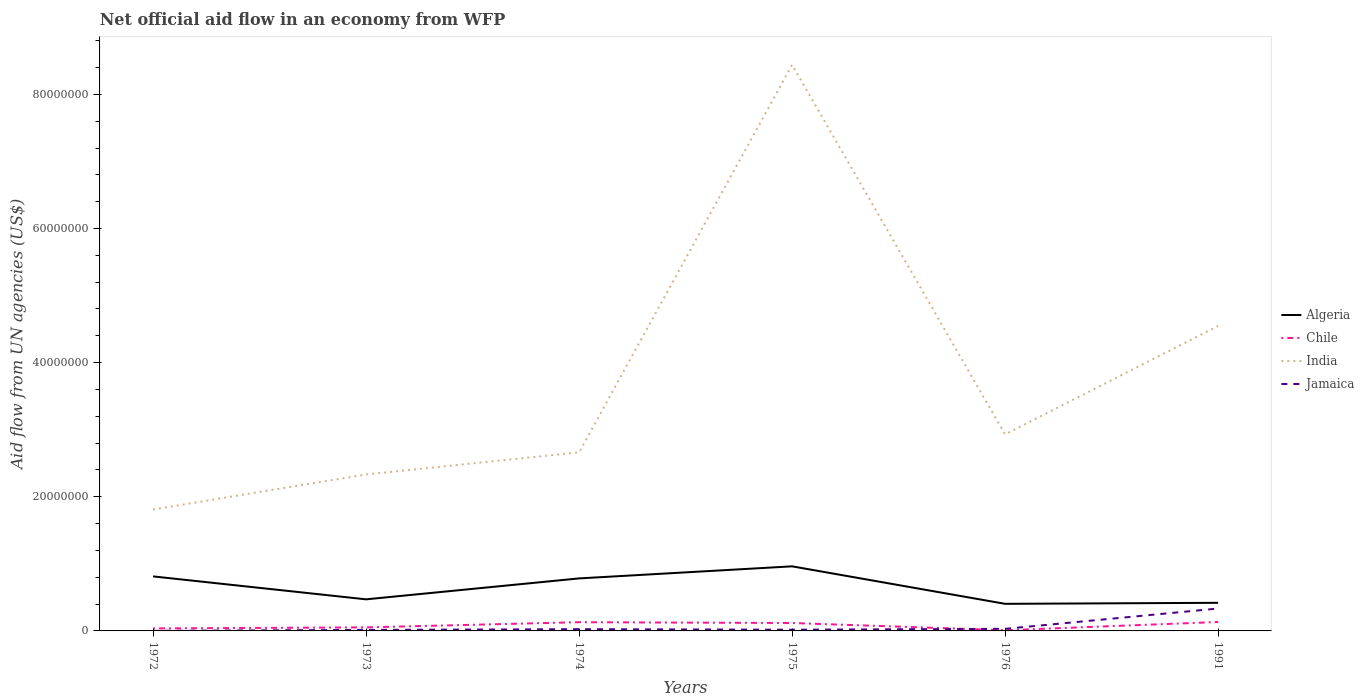How many different coloured lines are there?
Provide a short and direct response. 4. Does the line corresponding to Algeria intersect with the line corresponding to India?
Keep it short and to the point. No. Across all years, what is the maximum net official aid flow in India?
Offer a terse response. 1.81e+07. In which year was the net official aid flow in Algeria maximum?
Make the answer very short. 1976. What is the total net official aid flow in India in the graph?
Provide a succinct answer. -5.78e+07. What is the difference between the highest and the second highest net official aid flow in Algeria?
Your answer should be compact. 5.59e+06. How many lines are there?
Offer a terse response. 4. How many years are there in the graph?
Give a very brief answer. 6. Does the graph contain any zero values?
Make the answer very short. No. Where does the legend appear in the graph?
Your answer should be very brief. Center right. How many legend labels are there?
Make the answer very short. 4. How are the legend labels stacked?
Your answer should be very brief. Vertical. What is the title of the graph?
Make the answer very short. Net official aid flow in an economy from WFP. Does "Equatorial Guinea" appear as one of the legend labels in the graph?
Keep it short and to the point. No. What is the label or title of the Y-axis?
Provide a short and direct response. Aid flow from UN agencies (US$). What is the Aid flow from UN agencies (US$) in Algeria in 1972?
Give a very brief answer. 8.13e+06. What is the Aid flow from UN agencies (US$) in Chile in 1972?
Your answer should be very brief. 3.70e+05. What is the Aid flow from UN agencies (US$) of India in 1972?
Provide a succinct answer. 1.81e+07. What is the Aid flow from UN agencies (US$) in Algeria in 1973?
Your answer should be very brief. 4.71e+06. What is the Aid flow from UN agencies (US$) of Chile in 1973?
Offer a very short reply. 5.30e+05. What is the Aid flow from UN agencies (US$) in India in 1973?
Provide a succinct answer. 2.33e+07. What is the Aid flow from UN agencies (US$) in Algeria in 1974?
Make the answer very short. 7.83e+06. What is the Aid flow from UN agencies (US$) in Chile in 1974?
Your response must be concise. 1.30e+06. What is the Aid flow from UN agencies (US$) in India in 1974?
Ensure brevity in your answer.  2.66e+07. What is the Aid flow from UN agencies (US$) of Jamaica in 1974?
Provide a short and direct response. 2.60e+05. What is the Aid flow from UN agencies (US$) in Algeria in 1975?
Keep it short and to the point. 9.63e+06. What is the Aid flow from UN agencies (US$) of Chile in 1975?
Ensure brevity in your answer.  1.18e+06. What is the Aid flow from UN agencies (US$) in India in 1975?
Your answer should be very brief. 8.44e+07. What is the Aid flow from UN agencies (US$) of Algeria in 1976?
Ensure brevity in your answer.  4.04e+06. What is the Aid flow from UN agencies (US$) of Chile in 1976?
Offer a very short reply. 1.00e+05. What is the Aid flow from UN agencies (US$) in India in 1976?
Keep it short and to the point. 2.93e+07. What is the Aid flow from UN agencies (US$) in Jamaica in 1976?
Ensure brevity in your answer.  3.10e+05. What is the Aid flow from UN agencies (US$) in Algeria in 1991?
Your response must be concise. 4.19e+06. What is the Aid flow from UN agencies (US$) of Chile in 1991?
Your answer should be compact. 1.33e+06. What is the Aid flow from UN agencies (US$) in India in 1991?
Your answer should be compact. 4.55e+07. What is the Aid flow from UN agencies (US$) in Jamaica in 1991?
Provide a succinct answer. 3.34e+06. Across all years, what is the maximum Aid flow from UN agencies (US$) of Algeria?
Provide a short and direct response. 9.63e+06. Across all years, what is the maximum Aid flow from UN agencies (US$) in Chile?
Provide a succinct answer. 1.33e+06. Across all years, what is the maximum Aid flow from UN agencies (US$) of India?
Ensure brevity in your answer.  8.44e+07. Across all years, what is the maximum Aid flow from UN agencies (US$) in Jamaica?
Ensure brevity in your answer.  3.34e+06. Across all years, what is the minimum Aid flow from UN agencies (US$) in Algeria?
Provide a short and direct response. 4.04e+06. Across all years, what is the minimum Aid flow from UN agencies (US$) of Chile?
Provide a succinct answer. 1.00e+05. Across all years, what is the minimum Aid flow from UN agencies (US$) of India?
Ensure brevity in your answer.  1.81e+07. What is the total Aid flow from UN agencies (US$) in Algeria in the graph?
Give a very brief answer. 3.85e+07. What is the total Aid flow from UN agencies (US$) of Chile in the graph?
Provide a short and direct response. 4.81e+06. What is the total Aid flow from UN agencies (US$) of India in the graph?
Your response must be concise. 2.27e+08. What is the total Aid flow from UN agencies (US$) of Jamaica in the graph?
Keep it short and to the point. 4.25e+06. What is the difference between the Aid flow from UN agencies (US$) in Algeria in 1972 and that in 1973?
Ensure brevity in your answer.  3.42e+06. What is the difference between the Aid flow from UN agencies (US$) of Chile in 1972 and that in 1973?
Make the answer very short. -1.60e+05. What is the difference between the Aid flow from UN agencies (US$) in India in 1972 and that in 1973?
Your answer should be very brief. -5.23e+06. What is the difference between the Aid flow from UN agencies (US$) in Algeria in 1972 and that in 1974?
Offer a very short reply. 3.00e+05. What is the difference between the Aid flow from UN agencies (US$) in Chile in 1972 and that in 1974?
Offer a very short reply. -9.30e+05. What is the difference between the Aid flow from UN agencies (US$) of India in 1972 and that in 1974?
Ensure brevity in your answer.  -8.53e+06. What is the difference between the Aid flow from UN agencies (US$) in Jamaica in 1972 and that in 1974?
Keep it short and to the point. -2.50e+05. What is the difference between the Aid flow from UN agencies (US$) of Algeria in 1972 and that in 1975?
Keep it short and to the point. -1.50e+06. What is the difference between the Aid flow from UN agencies (US$) of Chile in 1972 and that in 1975?
Ensure brevity in your answer.  -8.10e+05. What is the difference between the Aid flow from UN agencies (US$) of India in 1972 and that in 1975?
Your response must be concise. -6.63e+07. What is the difference between the Aid flow from UN agencies (US$) of Algeria in 1972 and that in 1976?
Give a very brief answer. 4.09e+06. What is the difference between the Aid flow from UN agencies (US$) of Chile in 1972 and that in 1976?
Offer a very short reply. 2.70e+05. What is the difference between the Aid flow from UN agencies (US$) of India in 1972 and that in 1976?
Your answer should be very brief. -1.12e+07. What is the difference between the Aid flow from UN agencies (US$) of Algeria in 1972 and that in 1991?
Offer a very short reply. 3.94e+06. What is the difference between the Aid flow from UN agencies (US$) in Chile in 1972 and that in 1991?
Your response must be concise. -9.60e+05. What is the difference between the Aid flow from UN agencies (US$) of India in 1972 and that in 1991?
Your answer should be compact. -2.74e+07. What is the difference between the Aid flow from UN agencies (US$) in Jamaica in 1972 and that in 1991?
Provide a short and direct response. -3.33e+06. What is the difference between the Aid flow from UN agencies (US$) of Algeria in 1973 and that in 1974?
Ensure brevity in your answer.  -3.12e+06. What is the difference between the Aid flow from UN agencies (US$) in Chile in 1973 and that in 1974?
Provide a succinct answer. -7.70e+05. What is the difference between the Aid flow from UN agencies (US$) in India in 1973 and that in 1974?
Make the answer very short. -3.30e+06. What is the difference between the Aid flow from UN agencies (US$) in Jamaica in 1973 and that in 1974?
Your response must be concise. -1.10e+05. What is the difference between the Aid flow from UN agencies (US$) of Algeria in 1973 and that in 1975?
Your answer should be very brief. -4.92e+06. What is the difference between the Aid flow from UN agencies (US$) of Chile in 1973 and that in 1975?
Offer a very short reply. -6.50e+05. What is the difference between the Aid flow from UN agencies (US$) of India in 1973 and that in 1975?
Keep it short and to the point. -6.11e+07. What is the difference between the Aid flow from UN agencies (US$) in Algeria in 1973 and that in 1976?
Your answer should be compact. 6.70e+05. What is the difference between the Aid flow from UN agencies (US$) of Chile in 1973 and that in 1976?
Keep it short and to the point. 4.30e+05. What is the difference between the Aid flow from UN agencies (US$) of India in 1973 and that in 1976?
Your answer should be very brief. -5.98e+06. What is the difference between the Aid flow from UN agencies (US$) of Algeria in 1973 and that in 1991?
Provide a short and direct response. 5.20e+05. What is the difference between the Aid flow from UN agencies (US$) in Chile in 1973 and that in 1991?
Offer a very short reply. -8.00e+05. What is the difference between the Aid flow from UN agencies (US$) in India in 1973 and that in 1991?
Offer a terse response. -2.21e+07. What is the difference between the Aid flow from UN agencies (US$) in Jamaica in 1973 and that in 1991?
Offer a terse response. -3.19e+06. What is the difference between the Aid flow from UN agencies (US$) of Algeria in 1974 and that in 1975?
Give a very brief answer. -1.80e+06. What is the difference between the Aid flow from UN agencies (US$) in India in 1974 and that in 1975?
Provide a succinct answer. -5.78e+07. What is the difference between the Aid flow from UN agencies (US$) of Jamaica in 1974 and that in 1975?
Provide a succinct answer. 8.00e+04. What is the difference between the Aid flow from UN agencies (US$) in Algeria in 1974 and that in 1976?
Keep it short and to the point. 3.79e+06. What is the difference between the Aid flow from UN agencies (US$) of Chile in 1974 and that in 1976?
Offer a terse response. 1.20e+06. What is the difference between the Aid flow from UN agencies (US$) in India in 1974 and that in 1976?
Your answer should be compact. -2.68e+06. What is the difference between the Aid flow from UN agencies (US$) of Jamaica in 1974 and that in 1976?
Offer a very short reply. -5.00e+04. What is the difference between the Aid flow from UN agencies (US$) in Algeria in 1974 and that in 1991?
Provide a short and direct response. 3.64e+06. What is the difference between the Aid flow from UN agencies (US$) of India in 1974 and that in 1991?
Ensure brevity in your answer.  -1.88e+07. What is the difference between the Aid flow from UN agencies (US$) of Jamaica in 1974 and that in 1991?
Offer a terse response. -3.08e+06. What is the difference between the Aid flow from UN agencies (US$) in Algeria in 1975 and that in 1976?
Provide a short and direct response. 5.59e+06. What is the difference between the Aid flow from UN agencies (US$) of Chile in 1975 and that in 1976?
Provide a short and direct response. 1.08e+06. What is the difference between the Aid flow from UN agencies (US$) of India in 1975 and that in 1976?
Your answer should be very brief. 5.51e+07. What is the difference between the Aid flow from UN agencies (US$) in Jamaica in 1975 and that in 1976?
Make the answer very short. -1.30e+05. What is the difference between the Aid flow from UN agencies (US$) in Algeria in 1975 and that in 1991?
Your answer should be very brief. 5.44e+06. What is the difference between the Aid flow from UN agencies (US$) in India in 1975 and that in 1991?
Your answer should be compact. 3.89e+07. What is the difference between the Aid flow from UN agencies (US$) in Jamaica in 1975 and that in 1991?
Give a very brief answer. -3.16e+06. What is the difference between the Aid flow from UN agencies (US$) in Chile in 1976 and that in 1991?
Keep it short and to the point. -1.23e+06. What is the difference between the Aid flow from UN agencies (US$) of India in 1976 and that in 1991?
Your response must be concise. -1.62e+07. What is the difference between the Aid flow from UN agencies (US$) in Jamaica in 1976 and that in 1991?
Make the answer very short. -3.03e+06. What is the difference between the Aid flow from UN agencies (US$) of Algeria in 1972 and the Aid flow from UN agencies (US$) of Chile in 1973?
Keep it short and to the point. 7.60e+06. What is the difference between the Aid flow from UN agencies (US$) in Algeria in 1972 and the Aid flow from UN agencies (US$) in India in 1973?
Your response must be concise. -1.52e+07. What is the difference between the Aid flow from UN agencies (US$) in Algeria in 1972 and the Aid flow from UN agencies (US$) in Jamaica in 1973?
Keep it short and to the point. 7.98e+06. What is the difference between the Aid flow from UN agencies (US$) in Chile in 1972 and the Aid flow from UN agencies (US$) in India in 1973?
Provide a succinct answer. -2.30e+07. What is the difference between the Aid flow from UN agencies (US$) in Chile in 1972 and the Aid flow from UN agencies (US$) in Jamaica in 1973?
Ensure brevity in your answer.  2.20e+05. What is the difference between the Aid flow from UN agencies (US$) in India in 1972 and the Aid flow from UN agencies (US$) in Jamaica in 1973?
Keep it short and to the point. 1.80e+07. What is the difference between the Aid flow from UN agencies (US$) in Algeria in 1972 and the Aid flow from UN agencies (US$) in Chile in 1974?
Make the answer very short. 6.83e+06. What is the difference between the Aid flow from UN agencies (US$) of Algeria in 1972 and the Aid flow from UN agencies (US$) of India in 1974?
Provide a succinct answer. -1.85e+07. What is the difference between the Aid flow from UN agencies (US$) in Algeria in 1972 and the Aid flow from UN agencies (US$) in Jamaica in 1974?
Your response must be concise. 7.87e+06. What is the difference between the Aid flow from UN agencies (US$) in Chile in 1972 and the Aid flow from UN agencies (US$) in India in 1974?
Offer a very short reply. -2.63e+07. What is the difference between the Aid flow from UN agencies (US$) in India in 1972 and the Aid flow from UN agencies (US$) in Jamaica in 1974?
Offer a terse response. 1.78e+07. What is the difference between the Aid flow from UN agencies (US$) of Algeria in 1972 and the Aid flow from UN agencies (US$) of Chile in 1975?
Provide a short and direct response. 6.95e+06. What is the difference between the Aid flow from UN agencies (US$) in Algeria in 1972 and the Aid flow from UN agencies (US$) in India in 1975?
Offer a very short reply. -7.63e+07. What is the difference between the Aid flow from UN agencies (US$) in Algeria in 1972 and the Aid flow from UN agencies (US$) in Jamaica in 1975?
Provide a short and direct response. 7.95e+06. What is the difference between the Aid flow from UN agencies (US$) of Chile in 1972 and the Aid flow from UN agencies (US$) of India in 1975?
Ensure brevity in your answer.  -8.40e+07. What is the difference between the Aid flow from UN agencies (US$) in Chile in 1972 and the Aid flow from UN agencies (US$) in Jamaica in 1975?
Give a very brief answer. 1.90e+05. What is the difference between the Aid flow from UN agencies (US$) in India in 1972 and the Aid flow from UN agencies (US$) in Jamaica in 1975?
Provide a short and direct response. 1.79e+07. What is the difference between the Aid flow from UN agencies (US$) in Algeria in 1972 and the Aid flow from UN agencies (US$) in Chile in 1976?
Offer a very short reply. 8.03e+06. What is the difference between the Aid flow from UN agencies (US$) of Algeria in 1972 and the Aid flow from UN agencies (US$) of India in 1976?
Your answer should be very brief. -2.12e+07. What is the difference between the Aid flow from UN agencies (US$) in Algeria in 1972 and the Aid flow from UN agencies (US$) in Jamaica in 1976?
Ensure brevity in your answer.  7.82e+06. What is the difference between the Aid flow from UN agencies (US$) in Chile in 1972 and the Aid flow from UN agencies (US$) in India in 1976?
Provide a short and direct response. -2.89e+07. What is the difference between the Aid flow from UN agencies (US$) in India in 1972 and the Aid flow from UN agencies (US$) in Jamaica in 1976?
Ensure brevity in your answer.  1.78e+07. What is the difference between the Aid flow from UN agencies (US$) of Algeria in 1972 and the Aid flow from UN agencies (US$) of Chile in 1991?
Provide a succinct answer. 6.80e+06. What is the difference between the Aid flow from UN agencies (US$) in Algeria in 1972 and the Aid flow from UN agencies (US$) in India in 1991?
Provide a succinct answer. -3.73e+07. What is the difference between the Aid flow from UN agencies (US$) in Algeria in 1972 and the Aid flow from UN agencies (US$) in Jamaica in 1991?
Provide a succinct answer. 4.79e+06. What is the difference between the Aid flow from UN agencies (US$) in Chile in 1972 and the Aid flow from UN agencies (US$) in India in 1991?
Give a very brief answer. -4.51e+07. What is the difference between the Aid flow from UN agencies (US$) in Chile in 1972 and the Aid flow from UN agencies (US$) in Jamaica in 1991?
Your answer should be very brief. -2.97e+06. What is the difference between the Aid flow from UN agencies (US$) in India in 1972 and the Aid flow from UN agencies (US$) in Jamaica in 1991?
Ensure brevity in your answer.  1.48e+07. What is the difference between the Aid flow from UN agencies (US$) of Algeria in 1973 and the Aid flow from UN agencies (US$) of Chile in 1974?
Offer a very short reply. 3.41e+06. What is the difference between the Aid flow from UN agencies (US$) in Algeria in 1973 and the Aid flow from UN agencies (US$) in India in 1974?
Ensure brevity in your answer.  -2.19e+07. What is the difference between the Aid flow from UN agencies (US$) in Algeria in 1973 and the Aid flow from UN agencies (US$) in Jamaica in 1974?
Keep it short and to the point. 4.45e+06. What is the difference between the Aid flow from UN agencies (US$) in Chile in 1973 and the Aid flow from UN agencies (US$) in India in 1974?
Provide a short and direct response. -2.61e+07. What is the difference between the Aid flow from UN agencies (US$) in India in 1973 and the Aid flow from UN agencies (US$) in Jamaica in 1974?
Your answer should be compact. 2.31e+07. What is the difference between the Aid flow from UN agencies (US$) of Algeria in 1973 and the Aid flow from UN agencies (US$) of Chile in 1975?
Provide a succinct answer. 3.53e+06. What is the difference between the Aid flow from UN agencies (US$) of Algeria in 1973 and the Aid flow from UN agencies (US$) of India in 1975?
Keep it short and to the point. -7.97e+07. What is the difference between the Aid flow from UN agencies (US$) of Algeria in 1973 and the Aid flow from UN agencies (US$) of Jamaica in 1975?
Your response must be concise. 4.53e+06. What is the difference between the Aid flow from UN agencies (US$) of Chile in 1973 and the Aid flow from UN agencies (US$) of India in 1975?
Keep it short and to the point. -8.39e+07. What is the difference between the Aid flow from UN agencies (US$) of India in 1973 and the Aid flow from UN agencies (US$) of Jamaica in 1975?
Your answer should be compact. 2.32e+07. What is the difference between the Aid flow from UN agencies (US$) of Algeria in 1973 and the Aid flow from UN agencies (US$) of Chile in 1976?
Keep it short and to the point. 4.61e+06. What is the difference between the Aid flow from UN agencies (US$) in Algeria in 1973 and the Aid flow from UN agencies (US$) in India in 1976?
Ensure brevity in your answer.  -2.46e+07. What is the difference between the Aid flow from UN agencies (US$) in Algeria in 1973 and the Aid flow from UN agencies (US$) in Jamaica in 1976?
Provide a short and direct response. 4.40e+06. What is the difference between the Aid flow from UN agencies (US$) of Chile in 1973 and the Aid flow from UN agencies (US$) of India in 1976?
Offer a very short reply. -2.88e+07. What is the difference between the Aid flow from UN agencies (US$) of Chile in 1973 and the Aid flow from UN agencies (US$) of Jamaica in 1976?
Make the answer very short. 2.20e+05. What is the difference between the Aid flow from UN agencies (US$) in India in 1973 and the Aid flow from UN agencies (US$) in Jamaica in 1976?
Keep it short and to the point. 2.30e+07. What is the difference between the Aid flow from UN agencies (US$) of Algeria in 1973 and the Aid flow from UN agencies (US$) of Chile in 1991?
Provide a succinct answer. 3.38e+06. What is the difference between the Aid flow from UN agencies (US$) in Algeria in 1973 and the Aid flow from UN agencies (US$) in India in 1991?
Offer a terse response. -4.08e+07. What is the difference between the Aid flow from UN agencies (US$) in Algeria in 1973 and the Aid flow from UN agencies (US$) in Jamaica in 1991?
Offer a terse response. 1.37e+06. What is the difference between the Aid flow from UN agencies (US$) of Chile in 1973 and the Aid flow from UN agencies (US$) of India in 1991?
Your answer should be very brief. -4.49e+07. What is the difference between the Aid flow from UN agencies (US$) of Chile in 1973 and the Aid flow from UN agencies (US$) of Jamaica in 1991?
Offer a terse response. -2.81e+06. What is the difference between the Aid flow from UN agencies (US$) of India in 1973 and the Aid flow from UN agencies (US$) of Jamaica in 1991?
Keep it short and to the point. 2.00e+07. What is the difference between the Aid flow from UN agencies (US$) in Algeria in 1974 and the Aid flow from UN agencies (US$) in Chile in 1975?
Your answer should be very brief. 6.65e+06. What is the difference between the Aid flow from UN agencies (US$) in Algeria in 1974 and the Aid flow from UN agencies (US$) in India in 1975?
Make the answer very short. -7.66e+07. What is the difference between the Aid flow from UN agencies (US$) of Algeria in 1974 and the Aid flow from UN agencies (US$) of Jamaica in 1975?
Give a very brief answer. 7.65e+06. What is the difference between the Aid flow from UN agencies (US$) in Chile in 1974 and the Aid flow from UN agencies (US$) in India in 1975?
Offer a very short reply. -8.31e+07. What is the difference between the Aid flow from UN agencies (US$) in Chile in 1974 and the Aid flow from UN agencies (US$) in Jamaica in 1975?
Your response must be concise. 1.12e+06. What is the difference between the Aid flow from UN agencies (US$) of India in 1974 and the Aid flow from UN agencies (US$) of Jamaica in 1975?
Your answer should be very brief. 2.64e+07. What is the difference between the Aid flow from UN agencies (US$) in Algeria in 1974 and the Aid flow from UN agencies (US$) in Chile in 1976?
Give a very brief answer. 7.73e+06. What is the difference between the Aid flow from UN agencies (US$) in Algeria in 1974 and the Aid flow from UN agencies (US$) in India in 1976?
Your answer should be compact. -2.15e+07. What is the difference between the Aid flow from UN agencies (US$) in Algeria in 1974 and the Aid flow from UN agencies (US$) in Jamaica in 1976?
Ensure brevity in your answer.  7.52e+06. What is the difference between the Aid flow from UN agencies (US$) of Chile in 1974 and the Aid flow from UN agencies (US$) of India in 1976?
Ensure brevity in your answer.  -2.80e+07. What is the difference between the Aid flow from UN agencies (US$) of Chile in 1974 and the Aid flow from UN agencies (US$) of Jamaica in 1976?
Your response must be concise. 9.90e+05. What is the difference between the Aid flow from UN agencies (US$) in India in 1974 and the Aid flow from UN agencies (US$) in Jamaica in 1976?
Your response must be concise. 2.63e+07. What is the difference between the Aid flow from UN agencies (US$) of Algeria in 1974 and the Aid flow from UN agencies (US$) of Chile in 1991?
Your response must be concise. 6.50e+06. What is the difference between the Aid flow from UN agencies (US$) of Algeria in 1974 and the Aid flow from UN agencies (US$) of India in 1991?
Your answer should be very brief. -3.76e+07. What is the difference between the Aid flow from UN agencies (US$) in Algeria in 1974 and the Aid flow from UN agencies (US$) in Jamaica in 1991?
Offer a very short reply. 4.49e+06. What is the difference between the Aid flow from UN agencies (US$) of Chile in 1974 and the Aid flow from UN agencies (US$) of India in 1991?
Your response must be concise. -4.42e+07. What is the difference between the Aid flow from UN agencies (US$) of Chile in 1974 and the Aid flow from UN agencies (US$) of Jamaica in 1991?
Provide a succinct answer. -2.04e+06. What is the difference between the Aid flow from UN agencies (US$) in India in 1974 and the Aid flow from UN agencies (US$) in Jamaica in 1991?
Offer a very short reply. 2.33e+07. What is the difference between the Aid flow from UN agencies (US$) in Algeria in 1975 and the Aid flow from UN agencies (US$) in Chile in 1976?
Give a very brief answer. 9.53e+06. What is the difference between the Aid flow from UN agencies (US$) of Algeria in 1975 and the Aid flow from UN agencies (US$) of India in 1976?
Make the answer very short. -1.97e+07. What is the difference between the Aid flow from UN agencies (US$) in Algeria in 1975 and the Aid flow from UN agencies (US$) in Jamaica in 1976?
Ensure brevity in your answer.  9.32e+06. What is the difference between the Aid flow from UN agencies (US$) in Chile in 1975 and the Aid flow from UN agencies (US$) in India in 1976?
Provide a short and direct response. -2.81e+07. What is the difference between the Aid flow from UN agencies (US$) of Chile in 1975 and the Aid flow from UN agencies (US$) of Jamaica in 1976?
Your response must be concise. 8.70e+05. What is the difference between the Aid flow from UN agencies (US$) in India in 1975 and the Aid flow from UN agencies (US$) in Jamaica in 1976?
Give a very brief answer. 8.41e+07. What is the difference between the Aid flow from UN agencies (US$) in Algeria in 1975 and the Aid flow from UN agencies (US$) in Chile in 1991?
Your answer should be very brief. 8.30e+06. What is the difference between the Aid flow from UN agencies (US$) in Algeria in 1975 and the Aid flow from UN agencies (US$) in India in 1991?
Your response must be concise. -3.58e+07. What is the difference between the Aid flow from UN agencies (US$) in Algeria in 1975 and the Aid flow from UN agencies (US$) in Jamaica in 1991?
Keep it short and to the point. 6.29e+06. What is the difference between the Aid flow from UN agencies (US$) of Chile in 1975 and the Aid flow from UN agencies (US$) of India in 1991?
Keep it short and to the point. -4.43e+07. What is the difference between the Aid flow from UN agencies (US$) in Chile in 1975 and the Aid flow from UN agencies (US$) in Jamaica in 1991?
Provide a short and direct response. -2.16e+06. What is the difference between the Aid flow from UN agencies (US$) in India in 1975 and the Aid flow from UN agencies (US$) in Jamaica in 1991?
Ensure brevity in your answer.  8.11e+07. What is the difference between the Aid flow from UN agencies (US$) in Algeria in 1976 and the Aid flow from UN agencies (US$) in Chile in 1991?
Give a very brief answer. 2.71e+06. What is the difference between the Aid flow from UN agencies (US$) in Algeria in 1976 and the Aid flow from UN agencies (US$) in India in 1991?
Make the answer very short. -4.14e+07. What is the difference between the Aid flow from UN agencies (US$) of Chile in 1976 and the Aid flow from UN agencies (US$) of India in 1991?
Ensure brevity in your answer.  -4.54e+07. What is the difference between the Aid flow from UN agencies (US$) of Chile in 1976 and the Aid flow from UN agencies (US$) of Jamaica in 1991?
Give a very brief answer. -3.24e+06. What is the difference between the Aid flow from UN agencies (US$) of India in 1976 and the Aid flow from UN agencies (US$) of Jamaica in 1991?
Your response must be concise. 2.60e+07. What is the average Aid flow from UN agencies (US$) of Algeria per year?
Make the answer very short. 6.42e+06. What is the average Aid flow from UN agencies (US$) in Chile per year?
Keep it short and to the point. 8.02e+05. What is the average Aid flow from UN agencies (US$) in India per year?
Provide a short and direct response. 3.79e+07. What is the average Aid flow from UN agencies (US$) in Jamaica per year?
Ensure brevity in your answer.  7.08e+05. In the year 1972, what is the difference between the Aid flow from UN agencies (US$) in Algeria and Aid flow from UN agencies (US$) in Chile?
Offer a terse response. 7.76e+06. In the year 1972, what is the difference between the Aid flow from UN agencies (US$) in Algeria and Aid flow from UN agencies (US$) in India?
Offer a very short reply. -9.97e+06. In the year 1972, what is the difference between the Aid flow from UN agencies (US$) of Algeria and Aid flow from UN agencies (US$) of Jamaica?
Your answer should be very brief. 8.12e+06. In the year 1972, what is the difference between the Aid flow from UN agencies (US$) of Chile and Aid flow from UN agencies (US$) of India?
Keep it short and to the point. -1.77e+07. In the year 1972, what is the difference between the Aid flow from UN agencies (US$) of India and Aid flow from UN agencies (US$) of Jamaica?
Give a very brief answer. 1.81e+07. In the year 1973, what is the difference between the Aid flow from UN agencies (US$) of Algeria and Aid flow from UN agencies (US$) of Chile?
Keep it short and to the point. 4.18e+06. In the year 1973, what is the difference between the Aid flow from UN agencies (US$) in Algeria and Aid flow from UN agencies (US$) in India?
Your answer should be compact. -1.86e+07. In the year 1973, what is the difference between the Aid flow from UN agencies (US$) of Algeria and Aid flow from UN agencies (US$) of Jamaica?
Make the answer very short. 4.56e+06. In the year 1973, what is the difference between the Aid flow from UN agencies (US$) in Chile and Aid flow from UN agencies (US$) in India?
Your answer should be compact. -2.28e+07. In the year 1973, what is the difference between the Aid flow from UN agencies (US$) in Chile and Aid flow from UN agencies (US$) in Jamaica?
Make the answer very short. 3.80e+05. In the year 1973, what is the difference between the Aid flow from UN agencies (US$) in India and Aid flow from UN agencies (US$) in Jamaica?
Your answer should be compact. 2.32e+07. In the year 1974, what is the difference between the Aid flow from UN agencies (US$) in Algeria and Aid flow from UN agencies (US$) in Chile?
Make the answer very short. 6.53e+06. In the year 1974, what is the difference between the Aid flow from UN agencies (US$) of Algeria and Aid flow from UN agencies (US$) of India?
Provide a succinct answer. -1.88e+07. In the year 1974, what is the difference between the Aid flow from UN agencies (US$) in Algeria and Aid flow from UN agencies (US$) in Jamaica?
Your answer should be very brief. 7.57e+06. In the year 1974, what is the difference between the Aid flow from UN agencies (US$) of Chile and Aid flow from UN agencies (US$) of India?
Your answer should be very brief. -2.53e+07. In the year 1974, what is the difference between the Aid flow from UN agencies (US$) of Chile and Aid flow from UN agencies (US$) of Jamaica?
Your answer should be compact. 1.04e+06. In the year 1974, what is the difference between the Aid flow from UN agencies (US$) of India and Aid flow from UN agencies (US$) of Jamaica?
Your answer should be very brief. 2.64e+07. In the year 1975, what is the difference between the Aid flow from UN agencies (US$) of Algeria and Aid flow from UN agencies (US$) of Chile?
Offer a terse response. 8.45e+06. In the year 1975, what is the difference between the Aid flow from UN agencies (US$) in Algeria and Aid flow from UN agencies (US$) in India?
Make the answer very short. -7.48e+07. In the year 1975, what is the difference between the Aid flow from UN agencies (US$) in Algeria and Aid flow from UN agencies (US$) in Jamaica?
Your response must be concise. 9.45e+06. In the year 1975, what is the difference between the Aid flow from UN agencies (US$) in Chile and Aid flow from UN agencies (US$) in India?
Your answer should be very brief. -8.32e+07. In the year 1975, what is the difference between the Aid flow from UN agencies (US$) of Chile and Aid flow from UN agencies (US$) of Jamaica?
Give a very brief answer. 1.00e+06. In the year 1975, what is the difference between the Aid flow from UN agencies (US$) in India and Aid flow from UN agencies (US$) in Jamaica?
Offer a terse response. 8.42e+07. In the year 1976, what is the difference between the Aid flow from UN agencies (US$) of Algeria and Aid flow from UN agencies (US$) of Chile?
Keep it short and to the point. 3.94e+06. In the year 1976, what is the difference between the Aid flow from UN agencies (US$) in Algeria and Aid flow from UN agencies (US$) in India?
Ensure brevity in your answer.  -2.53e+07. In the year 1976, what is the difference between the Aid flow from UN agencies (US$) of Algeria and Aid flow from UN agencies (US$) of Jamaica?
Your answer should be very brief. 3.73e+06. In the year 1976, what is the difference between the Aid flow from UN agencies (US$) in Chile and Aid flow from UN agencies (US$) in India?
Provide a short and direct response. -2.92e+07. In the year 1976, what is the difference between the Aid flow from UN agencies (US$) of Chile and Aid flow from UN agencies (US$) of Jamaica?
Offer a very short reply. -2.10e+05. In the year 1976, what is the difference between the Aid flow from UN agencies (US$) of India and Aid flow from UN agencies (US$) of Jamaica?
Your answer should be very brief. 2.90e+07. In the year 1991, what is the difference between the Aid flow from UN agencies (US$) of Algeria and Aid flow from UN agencies (US$) of Chile?
Offer a terse response. 2.86e+06. In the year 1991, what is the difference between the Aid flow from UN agencies (US$) of Algeria and Aid flow from UN agencies (US$) of India?
Give a very brief answer. -4.13e+07. In the year 1991, what is the difference between the Aid flow from UN agencies (US$) of Algeria and Aid flow from UN agencies (US$) of Jamaica?
Provide a succinct answer. 8.50e+05. In the year 1991, what is the difference between the Aid flow from UN agencies (US$) in Chile and Aid flow from UN agencies (US$) in India?
Your response must be concise. -4.41e+07. In the year 1991, what is the difference between the Aid flow from UN agencies (US$) of Chile and Aid flow from UN agencies (US$) of Jamaica?
Make the answer very short. -2.01e+06. In the year 1991, what is the difference between the Aid flow from UN agencies (US$) of India and Aid flow from UN agencies (US$) of Jamaica?
Provide a succinct answer. 4.21e+07. What is the ratio of the Aid flow from UN agencies (US$) in Algeria in 1972 to that in 1973?
Ensure brevity in your answer.  1.73. What is the ratio of the Aid flow from UN agencies (US$) of Chile in 1972 to that in 1973?
Your answer should be compact. 0.7. What is the ratio of the Aid flow from UN agencies (US$) of India in 1972 to that in 1973?
Provide a short and direct response. 0.78. What is the ratio of the Aid flow from UN agencies (US$) of Jamaica in 1972 to that in 1973?
Your response must be concise. 0.07. What is the ratio of the Aid flow from UN agencies (US$) of Algeria in 1972 to that in 1974?
Your answer should be very brief. 1.04. What is the ratio of the Aid flow from UN agencies (US$) in Chile in 1972 to that in 1974?
Provide a short and direct response. 0.28. What is the ratio of the Aid flow from UN agencies (US$) of India in 1972 to that in 1974?
Your answer should be very brief. 0.68. What is the ratio of the Aid flow from UN agencies (US$) in Jamaica in 1972 to that in 1974?
Give a very brief answer. 0.04. What is the ratio of the Aid flow from UN agencies (US$) of Algeria in 1972 to that in 1975?
Provide a succinct answer. 0.84. What is the ratio of the Aid flow from UN agencies (US$) in Chile in 1972 to that in 1975?
Ensure brevity in your answer.  0.31. What is the ratio of the Aid flow from UN agencies (US$) in India in 1972 to that in 1975?
Offer a terse response. 0.21. What is the ratio of the Aid flow from UN agencies (US$) of Jamaica in 1972 to that in 1975?
Your answer should be compact. 0.06. What is the ratio of the Aid flow from UN agencies (US$) of Algeria in 1972 to that in 1976?
Your answer should be very brief. 2.01. What is the ratio of the Aid flow from UN agencies (US$) in India in 1972 to that in 1976?
Provide a succinct answer. 0.62. What is the ratio of the Aid flow from UN agencies (US$) in Jamaica in 1972 to that in 1976?
Keep it short and to the point. 0.03. What is the ratio of the Aid flow from UN agencies (US$) in Algeria in 1972 to that in 1991?
Your response must be concise. 1.94. What is the ratio of the Aid flow from UN agencies (US$) in Chile in 1972 to that in 1991?
Make the answer very short. 0.28. What is the ratio of the Aid flow from UN agencies (US$) in India in 1972 to that in 1991?
Offer a terse response. 0.4. What is the ratio of the Aid flow from UN agencies (US$) in Jamaica in 1972 to that in 1991?
Your answer should be compact. 0. What is the ratio of the Aid flow from UN agencies (US$) in Algeria in 1973 to that in 1974?
Your answer should be very brief. 0.6. What is the ratio of the Aid flow from UN agencies (US$) in Chile in 1973 to that in 1974?
Provide a short and direct response. 0.41. What is the ratio of the Aid flow from UN agencies (US$) of India in 1973 to that in 1974?
Offer a terse response. 0.88. What is the ratio of the Aid flow from UN agencies (US$) of Jamaica in 1973 to that in 1974?
Give a very brief answer. 0.58. What is the ratio of the Aid flow from UN agencies (US$) in Algeria in 1973 to that in 1975?
Your answer should be very brief. 0.49. What is the ratio of the Aid flow from UN agencies (US$) in Chile in 1973 to that in 1975?
Your answer should be very brief. 0.45. What is the ratio of the Aid flow from UN agencies (US$) of India in 1973 to that in 1975?
Make the answer very short. 0.28. What is the ratio of the Aid flow from UN agencies (US$) of Algeria in 1973 to that in 1976?
Keep it short and to the point. 1.17. What is the ratio of the Aid flow from UN agencies (US$) in India in 1973 to that in 1976?
Make the answer very short. 0.8. What is the ratio of the Aid flow from UN agencies (US$) in Jamaica in 1973 to that in 1976?
Provide a succinct answer. 0.48. What is the ratio of the Aid flow from UN agencies (US$) in Algeria in 1973 to that in 1991?
Ensure brevity in your answer.  1.12. What is the ratio of the Aid flow from UN agencies (US$) in Chile in 1973 to that in 1991?
Offer a terse response. 0.4. What is the ratio of the Aid flow from UN agencies (US$) in India in 1973 to that in 1991?
Keep it short and to the point. 0.51. What is the ratio of the Aid flow from UN agencies (US$) in Jamaica in 1973 to that in 1991?
Offer a terse response. 0.04. What is the ratio of the Aid flow from UN agencies (US$) of Algeria in 1974 to that in 1975?
Provide a short and direct response. 0.81. What is the ratio of the Aid flow from UN agencies (US$) of Chile in 1974 to that in 1975?
Ensure brevity in your answer.  1.1. What is the ratio of the Aid flow from UN agencies (US$) in India in 1974 to that in 1975?
Your response must be concise. 0.32. What is the ratio of the Aid flow from UN agencies (US$) of Jamaica in 1974 to that in 1975?
Provide a succinct answer. 1.44. What is the ratio of the Aid flow from UN agencies (US$) of Algeria in 1974 to that in 1976?
Your answer should be very brief. 1.94. What is the ratio of the Aid flow from UN agencies (US$) in Chile in 1974 to that in 1976?
Make the answer very short. 13. What is the ratio of the Aid flow from UN agencies (US$) in India in 1974 to that in 1976?
Provide a succinct answer. 0.91. What is the ratio of the Aid flow from UN agencies (US$) in Jamaica in 1974 to that in 1976?
Your answer should be very brief. 0.84. What is the ratio of the Aid flow from UN agencies (US$) of Algeria in 1974 to that in 1991?
Give a very brief answer. 1.87. What is the ratio of the Aid flow from UN agencies (US$) of Chile in 1974 to that in 1991?
Offer a very short reply. 0.98. What is the ratio of the Aid flow from UN agencies (US$) of India in 1974 to that in 1991?
Offer a very short reply. 0.59. What is the ratio of the Aid flow from UN agencies (US$) in Jamaica in 1974 to that in 1991?
Make the answer very short. 0.08. What is the ratio of the Aid flow from UN agencies (US$) of Algeria in 1975 to that in 1976?
Ensure brevity in your answer.  2.38. What is the ratio of the Aid flow from UN agencies (US$) in Chile in 1975 to that in 1976?
Your response must be concise. 11.8. What is the ratio of the Aid flow from UN agencies (US$) of India in 1975 to that in 1976?
Your answer should be compact. 2.88. What is the ratio of the Aid flow from UN agencies (US$) of Jamaica in 1975 to that in 1976?
Ensure brevity in your answer.  0.58. What is the ratio of the Aid flow from UN agencies (US$) of Algeria in 1975 to that in 1991?
Make the answer very short. 2.3. What is the ratio of the Aid flow from UN agencies (US$) of Chile in 1975 to that in 1991?
Provide a succinct answer. 0.89. What is the ratio of the Aid flow from UN agencies (US$) of India in 1975 to that in 1991?
Offer a terse response. 1.86. What is the ratio of the Aid flow from UN agencies (US$) in Jamaica in 1975 to that in 1991?
Ensure brevity in your answer.  0.05. What is the ratio of the Aid flow from UN agencies (US$) of Algeria in 1976 to that in 1991?
Ensure brevity in your answer.  0.96. What is the ratio of the Aid flow from UN agencies (US$) in Chile in 1976 to that in 1991?
Offer a very short reply. 0.08. What is the ratio of the Aid flow from UN agencies (US$) in India in 1976 to that in 1991?
Make the answer very short. 0.64. What is the ratio of the Aid flow from UN agencies (US$) of Jamaica in 1976 to that in 1991?
Keep it short and to the point. 0.09. What is the difference between the highest and the second highest Aid flow from UN agencies (US$) of Algeria?
Give a very brief answer. 1.50e+06. What is the difference between the highest and the second highest Aid flow from UN agencies (US$) in Chile?
Your answer should be compact. 3.00e+04. What is the difference between the highest and the second highest Aid flow from UN agencies (US$) in India?
Keep it short and to the point. 3.89e+07. What is the difference between the highest and the second highest Aid flow from UN agencies (US$) of Jamaica?
Make the answer very short. 3.03e+06. What is the difference between the highest and the lowest Aid flow from UN agencies (US$) of Algeria?
Provide a short and direct response. 5.59e+06. What is the difference between the highest and the lowest Aid flow from UN agencies (US$) of Chile?
Provide a short and direct response. 1.23e+06. What is the difference between the highest and the lowest Aid flow from UN agencies (US$) of India?
Offer a terse response. 6.63e+07. What is the difference between the highest and the lowest Aid flow from UN agencies (US$) of Jamaica?
Give a very brief answer. 3.33e+06. 